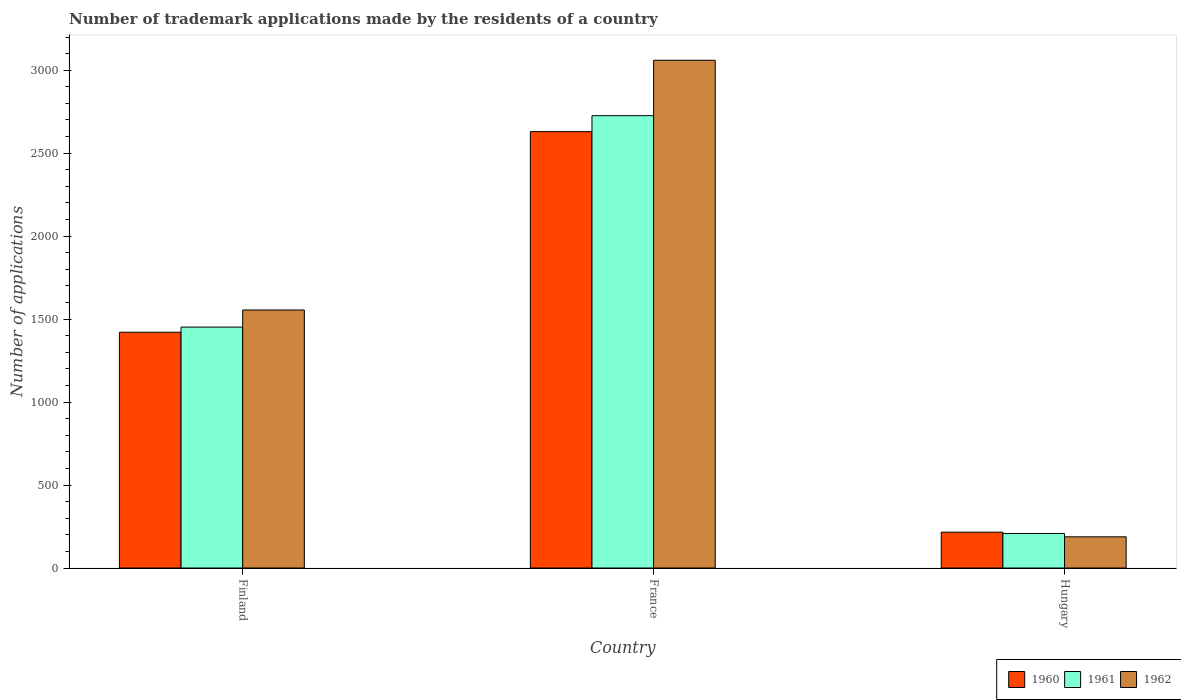How many different coloured bars are there?
Ensure brevity in your answer.  3. What is the label of the 3rd group of bars from the left?
Make the answer very short. Hungary. What is the number of trademark applications made by the residents in 1962 in France?
Provide a succinct answer. 3060. Across all countries, what is the maximum number of trademark applications made by the residents in 1960?
Make the answer very short. 2630. Across all countries, what is the minimum number of trademark applications made by the residents in 1961?
Your answer should be very brief. 208. In which country was the number of trademark applications made by the residents in 1960 maximum?
Your answer should be compact. France. In which country was the number of trademark applications made by the residents in 1961 minimum?
Make the answer very short. Hungary. What is the total number of trademark applications made by the residents in 1961 in the graph?
Offer a terse response. 4386. What is the difference between the number of trademark applications made by the residents in 1960 in France and that in Hungary?
Offer a very short reply. 2414. What is the difference between the number of trademark applications made by the residents in 1961 in France and the number of trademark applications made by the residents in 1960 in Hungary?
Keep it short and to the point. 2510. What is the average number of trademark applications made by the residents in 1960 per country?
Provide a succinct answer. 1422.33. What is the difference between the number of trademark applications made by the residents of/in 1961 and number of trademark applications made by the residents of/in 1962 in Hungary?
Your response must be concise. 20. What is the ratio of the number of trademark applications made by the residents in 1960 in France to that in Hungary?
Provide a succinct answer. 12.18. Is the number of trademark applications made by the residents in 1960 in Finland less than that in France?
Your answer should be compact. Yes. What is the difference between the highest and the second highest number of trademark applications made by the residents in 1962?
Give a very brief answer. -1367. What is the difference between the highest and the lowest number of trademark applications made by the residents in 1960?
Offer a terse response. 2414. Is the sum of the number of trademark applications made by the residents in 1962 in France and Hungary greater than the maximum number of trademark applications made by the residents in 1961 across all countries?
Provide a short and direct response. Yes. What does the 2nd bar from the left in Hungary represents?
Offer a very short reply. 1961. What does the 1st bar from the right in Finland represents?
Ensure brevity in your answer.  1962. Is it the case that in every country, the sum of the number of trademark applications made by the residents in 1960 and number of trademark applications made by the residents in 1961 is greater than the number of trademark applications made by the residents in 1962?
Offer a terse response. Yes. How many bars are there?
Make the answer very short. 9. Does the graph contain any zero values?
Provide a succinct answer. No. Where does the legend appear in the graph?
Your response must be concise. Bottom right. What is the title of the graph?
Keep it short and to the point. Number of trademark applications made by the residents of a country. What is the label or title of the X-axis?
Provide a short and direct response. Country. What is the label or title of the Y-axis?
Make the answer very short. Number of applications. What is the Number of applications of 1960 in Finland?
Offer a terse response. 1421. What is the Number of applications of 1961 in Finland?
Ensure brevity in your answer.  1452. What is the Number of applications of 1962 in Finland?
Offer a terse response. 1555. What is the Number of applications of 1960 in France?
Give a very brief answer. 2630. What is the Number of applications of 1961 in France?
Provide a short and direct response. 2726. What is the Number of applications of 1962 in France?
Your answer should be very brief. 3060. What is the Number of applications in 1960 in Hungary?
Make the answer very short. 216. What is the Number of applications of 1961 in Hungary?
Ensure brevity in your answer.  208. What is the Number of applications of 1962 in Hungary?
Ensure brevity in your answer.  188. Across all countries, what is the maximum Number of applications in 1960?
Give a very brief answer. 2630. Across all countries, what is the maximum Number of applications of 1961?
Provide a succinct answer. 2726. Across all countries, what is the maximum Number of applications in 1962?
Ensure brevity in your answer.  3060. Across all countries, what is the minimum Number of applications in 1960?
Offer a very short reply. 216. Across all countries, what is the minimum Number of applications in 1961?
Keep it short and to the point. 208. Across all countries, what is the minimum Number of applications in 1962?
Keep it short and to the point. 188. What is the total Number of applications in 1960 in the graph?
Keep it short and to the point. 4267. What is the total Number of applications in 1961 in the graph?
Make the answer very short. 4386. What is the total Number of applications in 1962 in the graph?
Offer a very short reply. 4803. What is the difference between the Number of applications of 1960 in Finland and that in France?
Provide a short and direct response. -1209. What is the difference between the Number of applications of 1961 in Finland and that in France?
Your answer should be very brief. -1274. What is the difference between the Number of applications of 1962 in Finland and that in France?
Offer a terse response. -1505. What is the difference between the Number of applications of 1960 in Finland and that in Hungary?
Provide a short and direct response. 1205. What is the difference between the Number of applications in 1961 in Finland and that in Hungary?
Provide a short and direct response. 1244. What is the difference between the Number of applications in 1962 in Finland and that in Hungary?
Offer a very short reply. 1367. What is the difference between the Number of applications of 1960 in France and that in Hungary?
Offer a terse response. 2414. What is the difference between the Number of applications of 1961 in France and that in Hungary?
Your response must be concise. 2518. What is the difference between the Number of applications in 1962 in France and that in Hungary?
Ensure brevity in your answer.  2872. What is the difference between the Number of applications of 1960 in Finland and the Number of applications of 1961 in France?
Offer a very short reply. -1305. What is the difference between the Number of applications in 1960 in Finland and the Number of applications in 1962 in France?
Provide a succinct answer. -1639. What is the difference between the Number of applications of 1961 in Finland and the Number of applications of 1962 in France?
Give a very brief answer. -1608. What is the difference between the Number of applications in 1960 in Finland and the Number of applications in 1961 in Hungary?
Provide a succinct answer. 1213. What is the difference between the Number of applications of 1960 in Finland and the Number of applications of 1962 in Hungary?
Offer a terse response. 1233. What is the difference between the Number of applications of 1961 in Finland and the Number of applications of 1962 in Hungary?
Give a very brief answer. 1264. What is the difference between the Number of applications in 1960 in France and the Number of applications in 1961 in Hungary?
Your response must be concise. 2422. What is the difference between the Number of applications of 1960 in France and the Number of applications of 1962 in Hungary?
Ensure brevity in your answer.  2442. What is the difference between the Number of applications in 1961 in France and the Number of applications in 1962 in Hungary?
Offer a very short reply. 2538. What is the average Number of applications in 1960 per country?
Your answer should be compact. 1422.33. What is the average Number of applications in 1961 per country?
Provide a short and direct response. 1462. What is the average Number of applications in 1962 per country?
Offer a terse response. 1601. What is the difference between the Number of applications in 1960 and Number of applications in 1961 in Finland?
Your answer should be compact. -31. What is the difference between the Number of applications of 1960 and Number of applications of 1962 in Finland?
Offer a terse response. -134. What is the difference between the Number of applications in 1961 and Number of applications in 1962 in Finland?
Your answer should be very brief. -103. What is the difference between the Number of applications of 1960 and Number of applications of 1961 in France?
Make the answer very short. -96. What is the difference between the Number of applications in 1960 and Number of applications in 1962 in France?
Your response must be concise. -430. What is the difference between the Number of applications in 1961 and Number of applications in 1962 in France?
Ensure brevity in your answer.  -334. What is the difference between the Number of applications in 1960 and Number of applications in 1961 in Hungary?
Offer a very short reply. 8. What is the difference between the Number of applications of 1961 and Number of applications of 1962 in Hungary?
Offer a very short reply. 20. What is the ratio of the Number of applications in 1960 in Finland to that in France?
Give a very brief answer. 0.54. What is the ratio of the Number of applications in 1961 in Finland to that in France?
Offer a very short reply. 0.53. What is the ratio of the Number of applications in 1962 in Finland to that in France?
Offer a terse response. 0.51. What is the ratio of the Number of applications in 1960 in Finland to that in Hungary?
Your answer should be very brief. 6.58. What is the ratio of the Number of applications of 1961 in Finland to that in Hungary?
Ensure brevity in your answer.  6.98. What is the ratio of the Number of applications in 1962 in Finland to that in Hungary?
Provide a short and direct response. 8.27. What is the ratio of the Number of applications of 1960 in France to that in Hungary?
Your response must be concise. 12.18. What is the ratio of the Number of applications in 1961 in France to that in Hungary?
Provide a short and direct response. 13.11. What is the ratio of the Number of applications of 1962 in France to that in Hungary?
Make the answer very short. 16.28. What is the difference between the highest and the second highest Number of applications of 1960?
Offer a terse response. 1209. What is the difference between the highest and the second highest Number of applications in 1961?
Make the answer very short. 1274. What is the difference between the highest and the second highest Number of applications in 1962?
Provide a short and direct response. 1505. What is the difference between the highest and the lowest Number of applications in 1960?
Make the answer very short. 2414. What is the difference between the highest and the lowest Number of applications in 1961?
Make the answer very short. 2518. What is the difference between the highest and the lowest Number of applications of 1962?
Ensure brevity in your answer.  2872. 